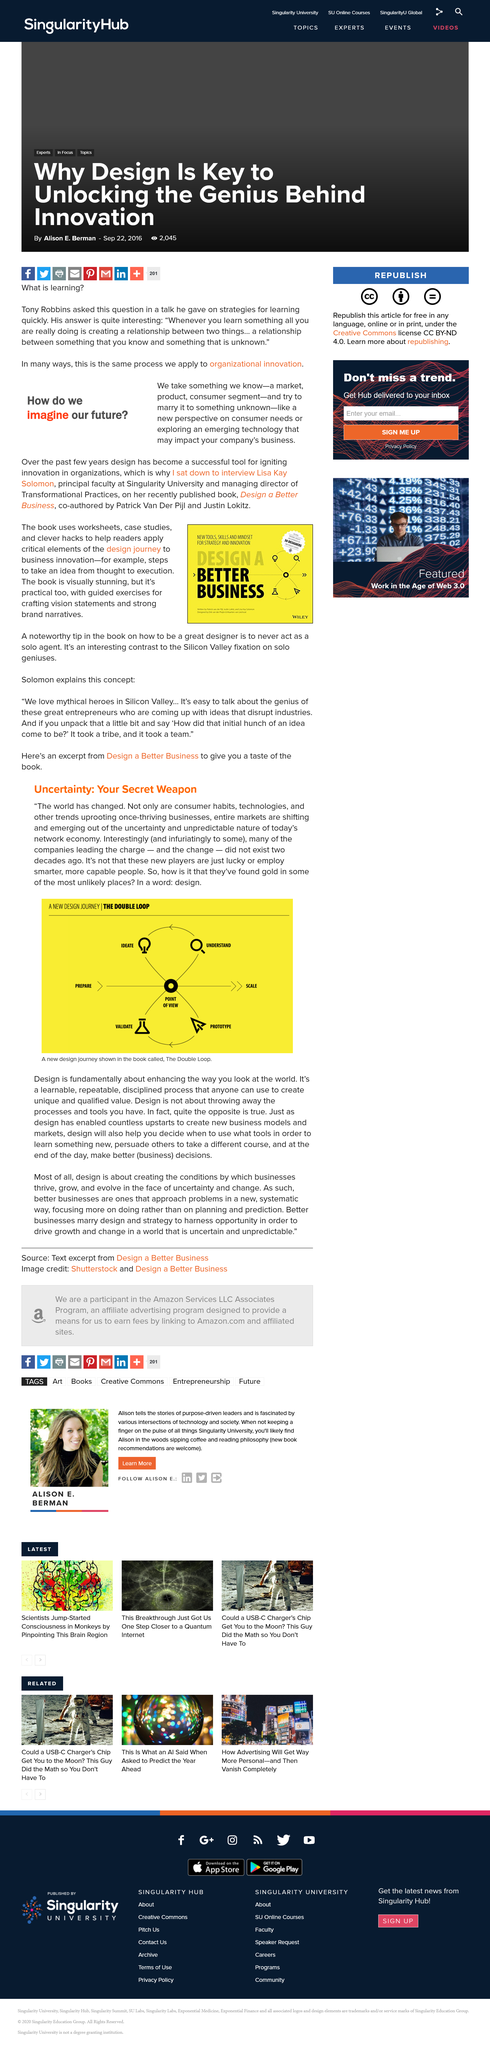Outline some significant characteristics in this image. The design journey comprises the steps of preparation, ideation, understanding, point of view, scaling, validation, and prototyping, as depicted in the diagram. The book mentioned is called 'The Double Loop: Strategic Decision Making and the Science of Choice' The recently published book was interviewed by an author named Lisa Kay Solomon. The book uses worksheets, case studies, and clever hacks to assist readers in their design journey. The authors of the recently published book are Lisa Kay Solomon, Patrick Van Far Pijl, and Justin Lokitz. 